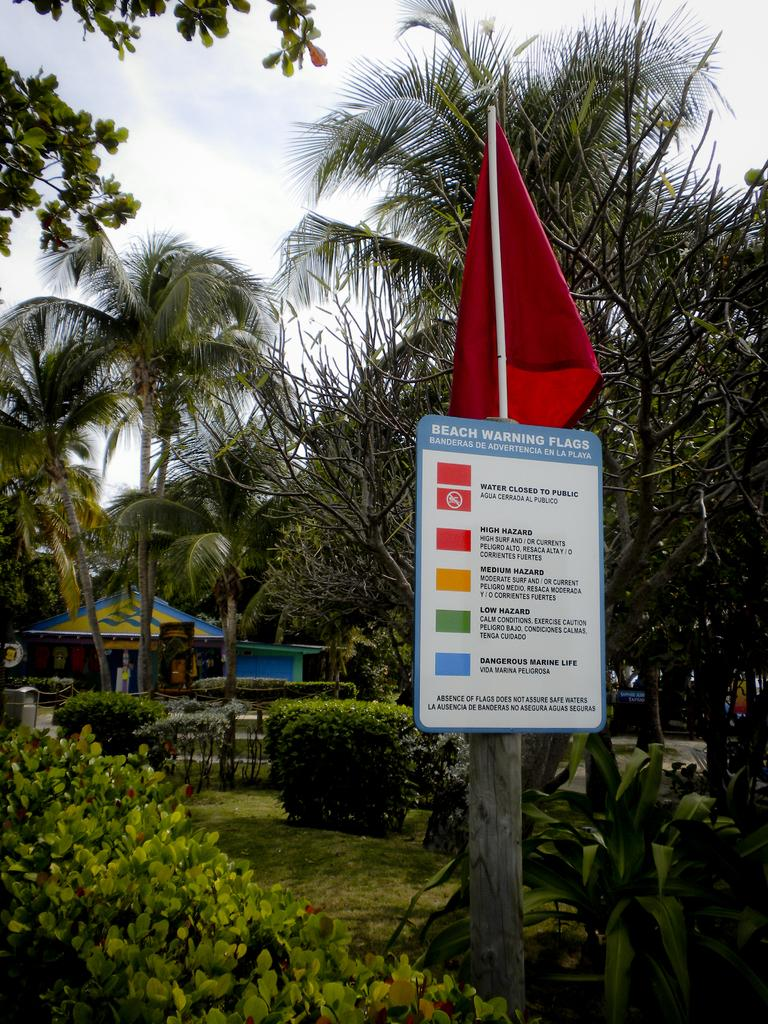What is written or depicted on the board in the image? There is a board with text in the image, but the specific content is not mentioned in the facts. What is the wooden pole used for in the image? The wooden pole's purpose is not mentioned in the facts. What is the flag attached to in the image? The flag is attached to the wooden pole in the image. What type of vegetation is present in the image? Grass is present in the image. What type of natural feature is visible in the image? There is a group of trees in the image. What type of structure is visible in the image? There is a house in the image. What is visible in the background of the image? The sky is visible in the image. How many beans are scattered on the ground in the image? There is no mention of beans in the image, so we cannot determine their presence or quantity. What type of rose can be seen growing near the house in the image? There is no mention of a rose in the image, so we cannot determine its presence or type. 